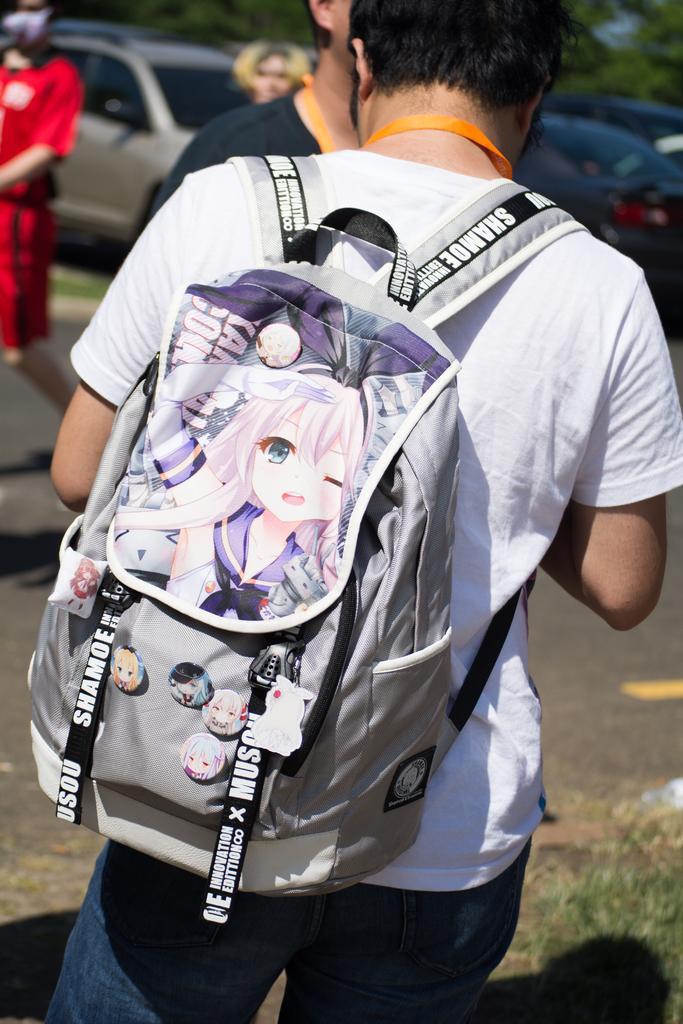Can you describe this image briefly? In this image, There is a man standing and he is carrying a bag of ash color, In the background there are some people walking and there are some cars and there are some trees in green color. 